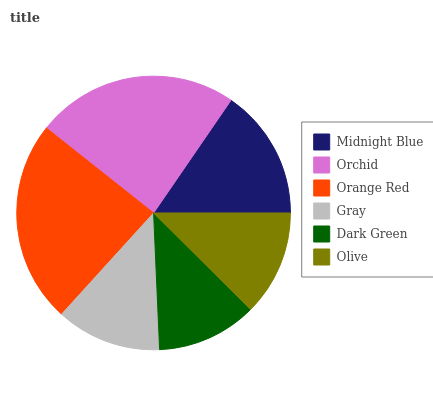Is Dark Green the minimum?
Answer yes or no. Yes. Is Orange Red the maximum?
Answer yes or no. Yes. Is Orchid the minimum?
Answer yes or no. No. Is Orchid the maximum?
Answer yes or no. No. Is Orchid greater than Midnight Blue?
Answer yes or no. Yes. Is Midnight Blue less than Orchid?
Answer yes or no. Yes. Is Midnight Blue greater than Orchid?
Answer yes or no. No. Is Orchid less than Midnight Blue?
Answer yes or no. No. Is Midnight Blue the high median?
Answer yes or no. Yes. Is Olive the low median?
Answer yes or no. Yes. Is Orchid the high median?
Answer yes or no. No. Is Orange Red the low median?
Answer yes or no. No. 